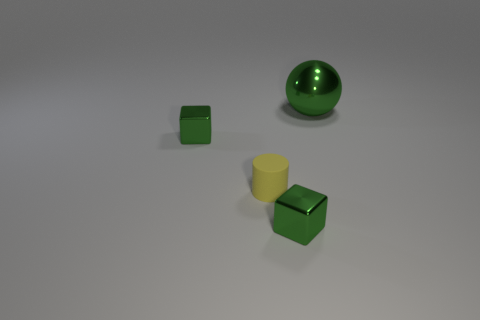Add 4 yellow things. How many objects exist? 8 Subtract all cylinders. How many objects are left? 3 Subtract all brown cubes. Subtract all red spheres. How many cubes are left? 2 Subtract all green cubes. How many brown spheres are left? 0 Subtract all large balls. Subtract all small yellow rubber cylinders. How many objects are left? 2 Add 2 yellow objects. How many yellow objects are left? 3 Add 1 big blue cubes. How many big blue cubes exist? 1 Subtract 0 brown blocks. How many objects are left? 4 Subtract 1 cylinders. How many cylinders are left? 0 